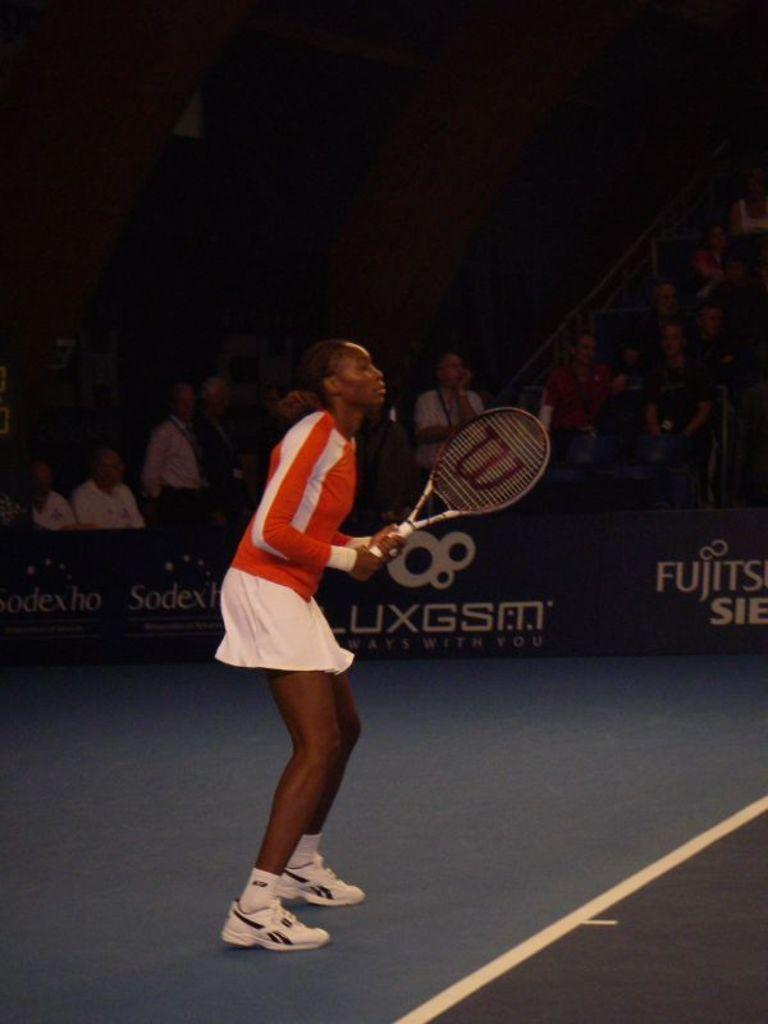Who is the main subject in the image? There is a woman in the image. What is the woman holding in the image? The woman is holding a racket. Can you describe the people in the background of the image? There are people in the image who appear to be an audience. What type of rule is being enforced by the cabbage in the image? There is no cabbage present in the image, and therefore no rule enforcement can be observed. 